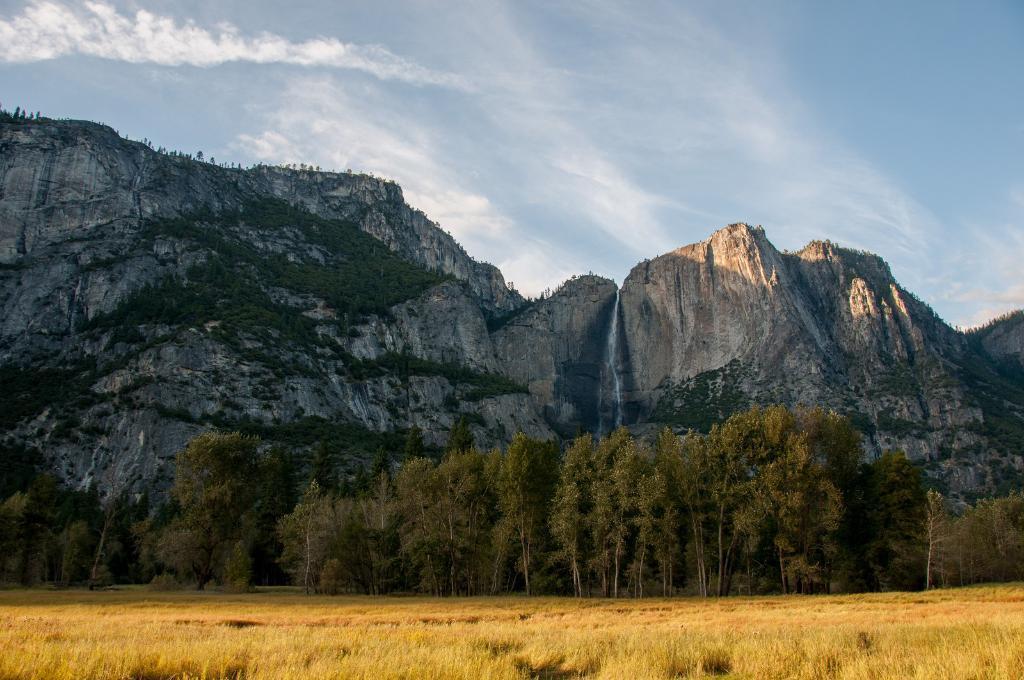Can you describe this image briefly? The picture is taken in a forest. In the foreground of the picture there are trees and field. In the center of the picture there is a mountain. On the mountain there are trees. Sky is clear and it is sunny. 